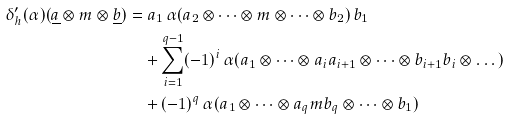<formula> <loc_0><loc_0><loc_500><loc_500>\delta ^ { \prime } _ { h } ( \alpha ) ( \underline { a } \otimes m \otimes \underline { b } ) = & \ a _ { 1 } \, \alpha ( a _ { 2 } \otimes \dots \otimes m \otimes \dots \otimes b _ { 2 } ) \, b _ { 1 } \\ \ & + \sum _ { i = 1 } ^ { q - 1 } ( - 1 ) ^ { i } \, \alpha ( a _ { 1 } \otimes \dots \otimes a _ { i } a _ { i + 1 } \otimes \dots \otimes b _ { i + 1 } b _ { i } \otimes \dots ) \\ \ & + ( - 1 ) ^ { q } \, \alpha ( a _ { 1 } \otimes \dots \otimes a _ { q } m b _ { q } \otimes \dots \otimes b _ { 1 } )</formula> 